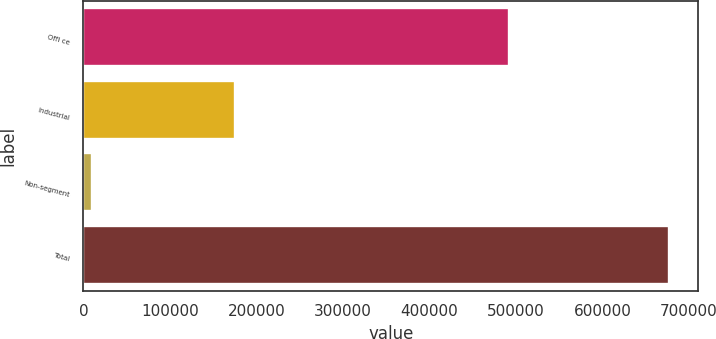<chart> <loc_0><loc_0><loc_500><loc_500><bar_chart><fcel>Offi ce<fcel>Industrial<fcel>Non-segment<fcel>Total<nl><fcel>491895<fcel>174963<fcel>9776<fcel>676634<nl></chart> 